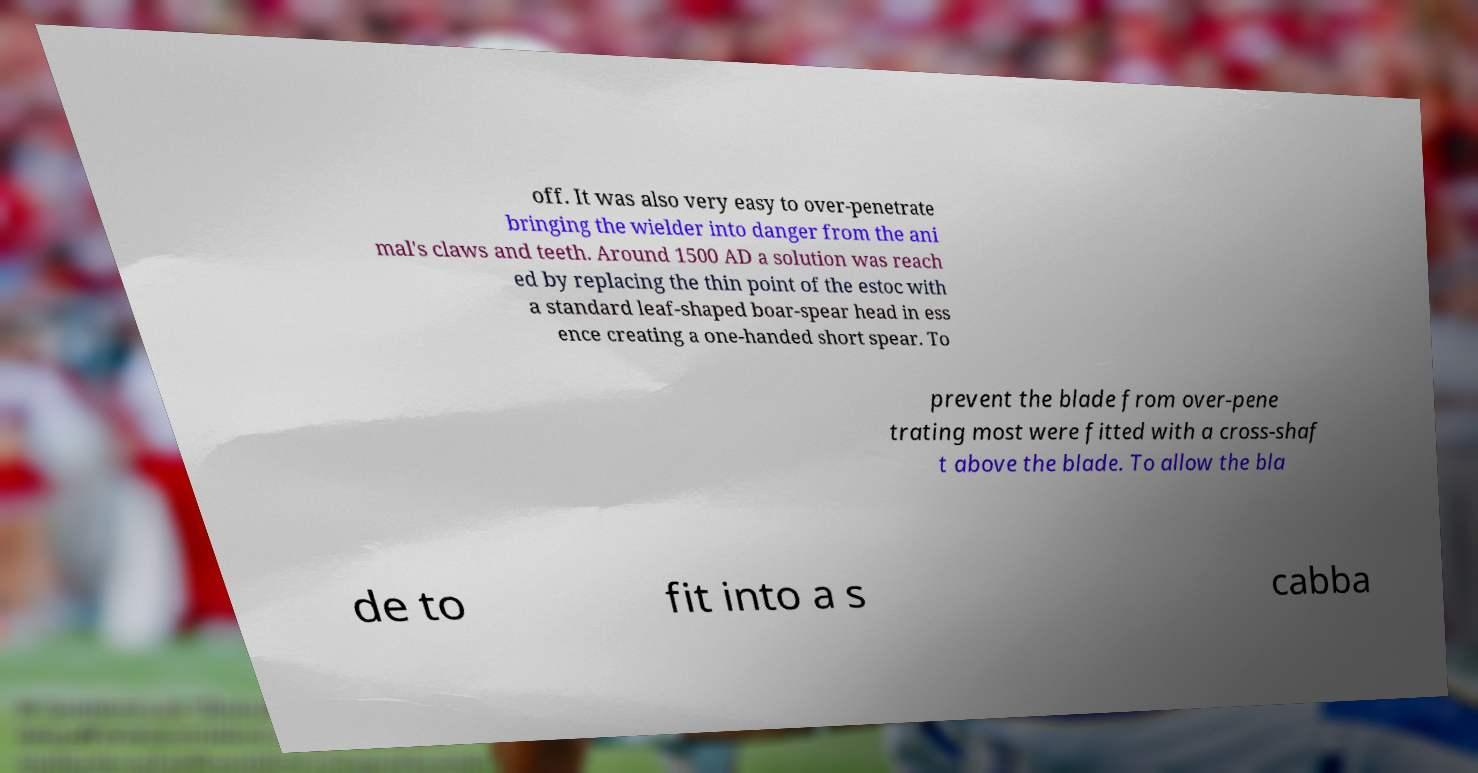For documentation purposes, I need the text within this image transcribed. Could you provide that? off. It was also very easy to over-penetrate bringing the wielder into danger from the ani mal's claws and teeth. Around 1500 AD a solution was reach ed by replacing the thin point of the estoc with a standard leaf-shaped boar-spear head in ess ence creating a one-handed short spear. To prevent the blade from over-pene trating most were fitted with a cross-shaf t above the blade. To allow the bla de to fit into a s cabba 